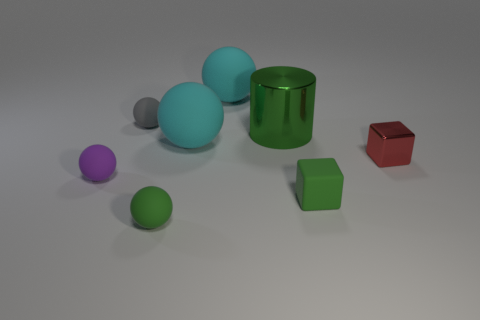There is a green thing behind the large cyan matte sphere that is in front of the small gray sphere; what shape is it?
Offer a terse response. Cylinder. There is another object that is the same shape as the red shiny thing; what is its material?
Offer a very short reply. Rubber. What color is the other block that is the same size as the red block?
Your answer should be very brief. Green. Are there an equal number of cyan balls that are right of the tiny red object and spheres?
Make the answer very short. No. There is a big matte sphere that is to the left of the cyan matte object that is behind the metallic cylinder; what is its color?
Provide a short and direct response. Cyan. There is a red object that is to the right of the block in front of the small red shiny object; how big is it?
Your answer should be very brief. Small. There is a matte sphere that is the same color as the big cylinder; what size is it?
Ensure brevity in your answer.  Small. How many other objects are there of the same size as the green metal cylinder?
Provide a succinct answer. 2. There is a rubber ball that is in front of the tiny rubber thing to the right of the green matte object on the left side of the big metal thing; what color is it?
Make the answer very short. Green. How many other things are there of the same shape as the large green object?
Ensure brevity in your answer.  0. 